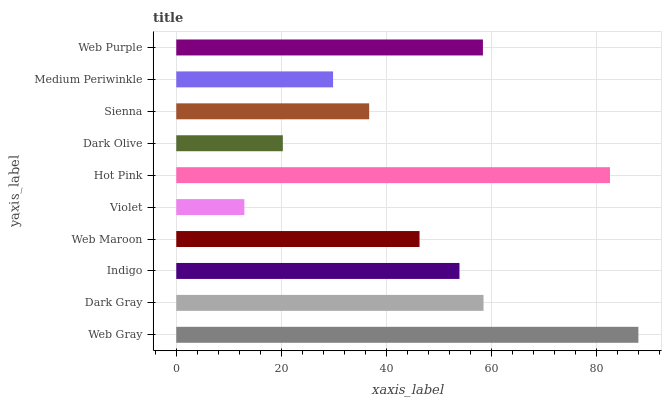Is Violet the minimum?
Answer yes or no. Yes. Is Web Gray the maximum?
Answer yes or no. Yes. Is Dark Gray the minimum?
Answer yes or no. No. Is Dark Gray the maximum?
Answer yes or no. No. Is Web Gray greater than Dark Gray?
Answer yes or no. Yes. Is Dark Gray less than Web Gray?
Answer yes or no. Yes. Is Dark Gray greater than Web Gray?
Answer yes or no. No. Is Web Gray less than Dark Gray?
Answer yes or no. No. Is Indigo the high median?
Answer yes or no. Yes. Is Web Maroon the low median?
Answer yes or no. Yes. Is Hot Pink the high median?
Answer yes or no. No. Is Hot Pink the low median?
Answer yes or no. No. 